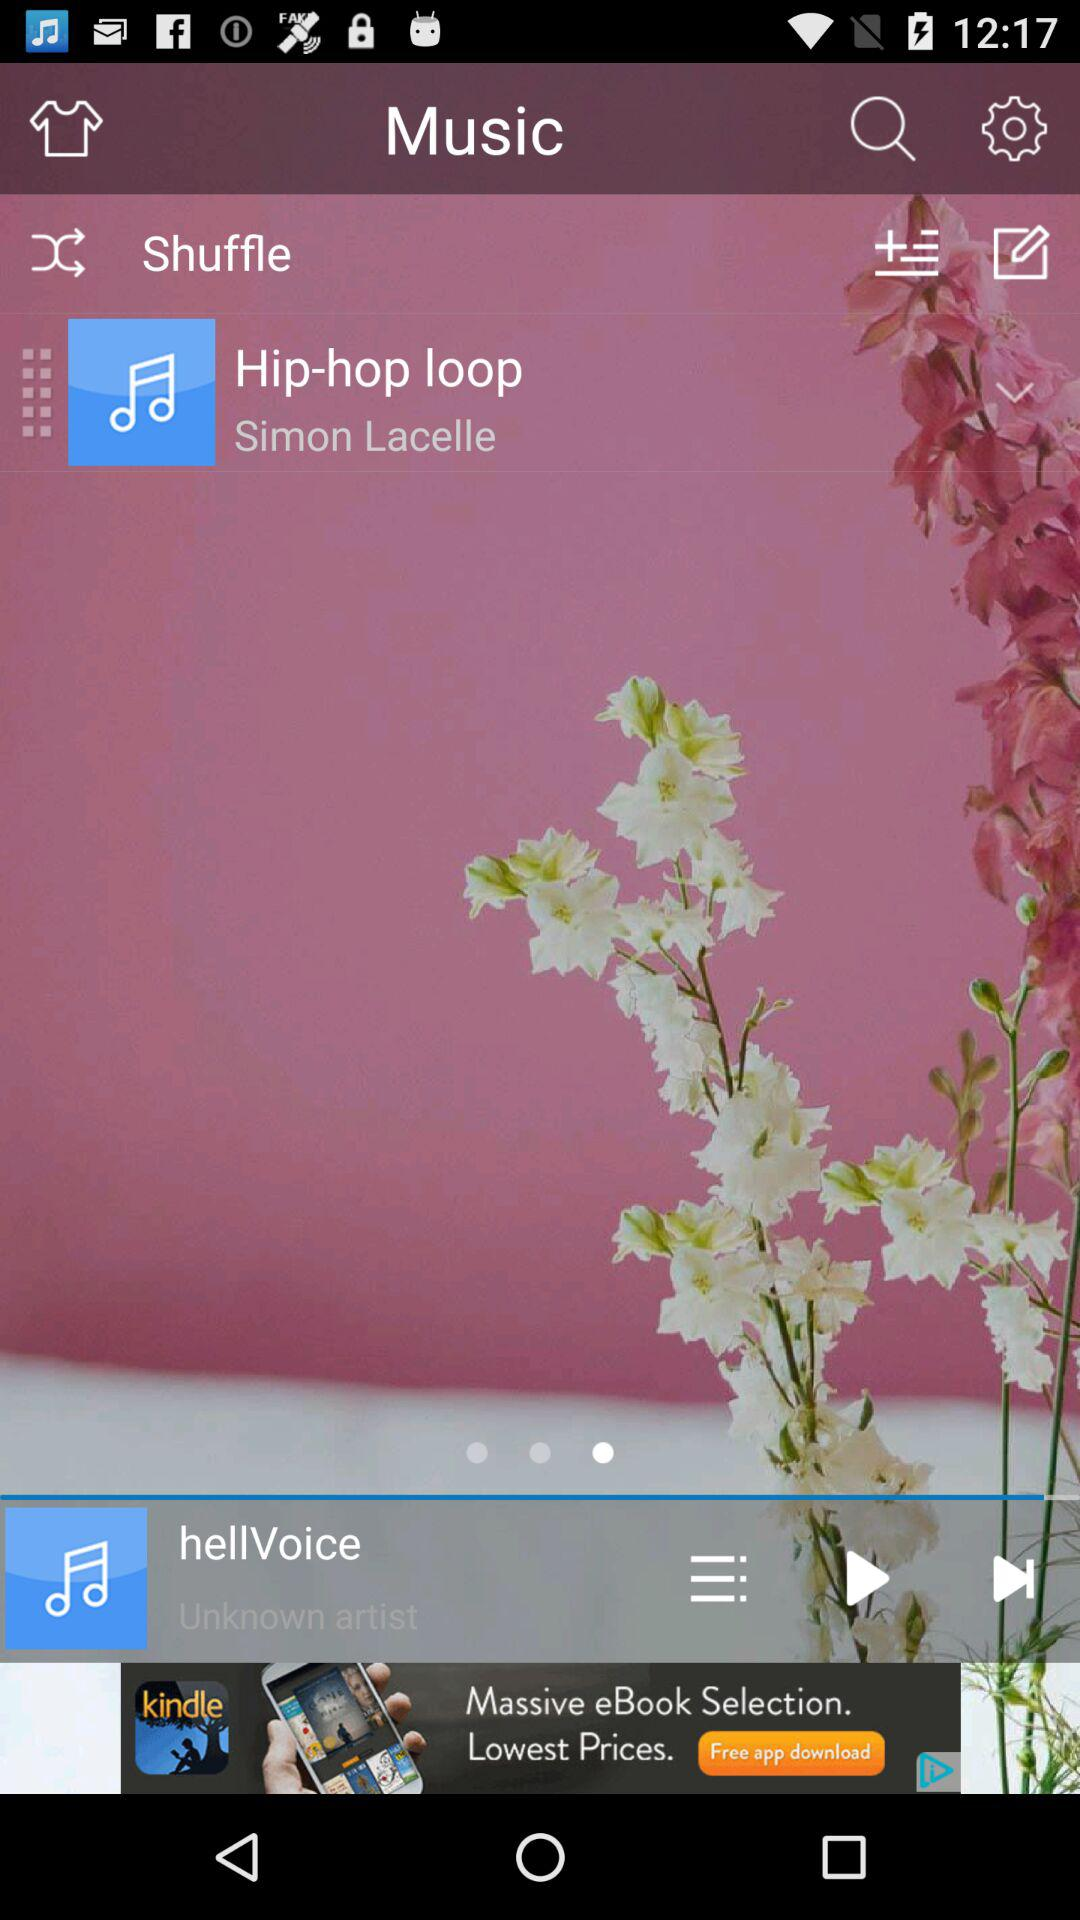Who is the singer of "Hip-hop loop"? The singer of "Hip-hop loop" is Simon Lacelle. 